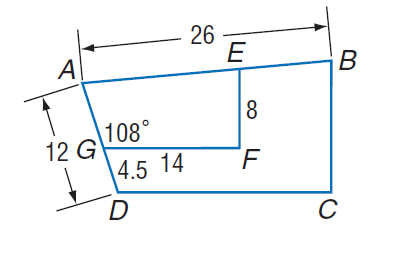Answer the mathemtical geometry problem and directly provide the correct option letter.
Question: Polygon A B C D \sim polygon A E F G, m \angle A G F = 108, G F = 14, A D = 12, D G = 4.5, E F = 8, and A B = 26. Find the perimeter of trapezoid A E F G.
Choices: A: 4.575 B: 12 C: 26 D: 45.75 D 